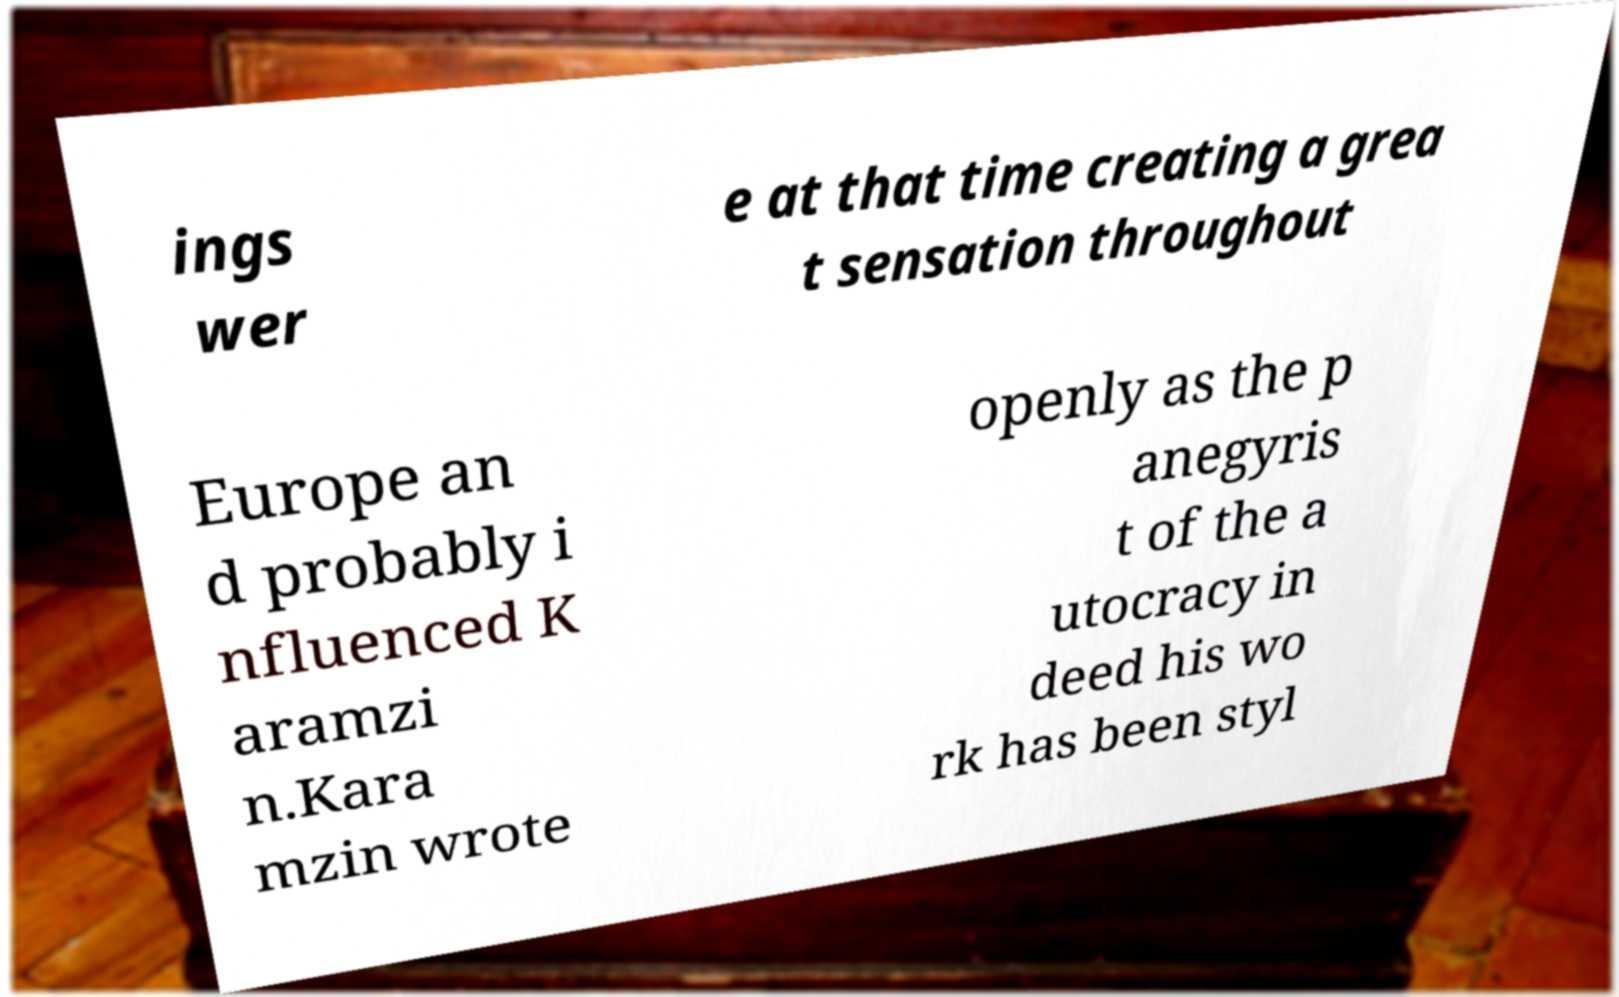Can you read and provide the text displayed in the image?This photo seems to have some interesting text. Can you extract and type it out for me? ings wer e at that time creating a grea t sensation throughout Europe an d probably i nfluenced K aramzi n.Kara mzin wrote openly as the p anegyris t of the a utocracy in deed his wo rk has been styl 